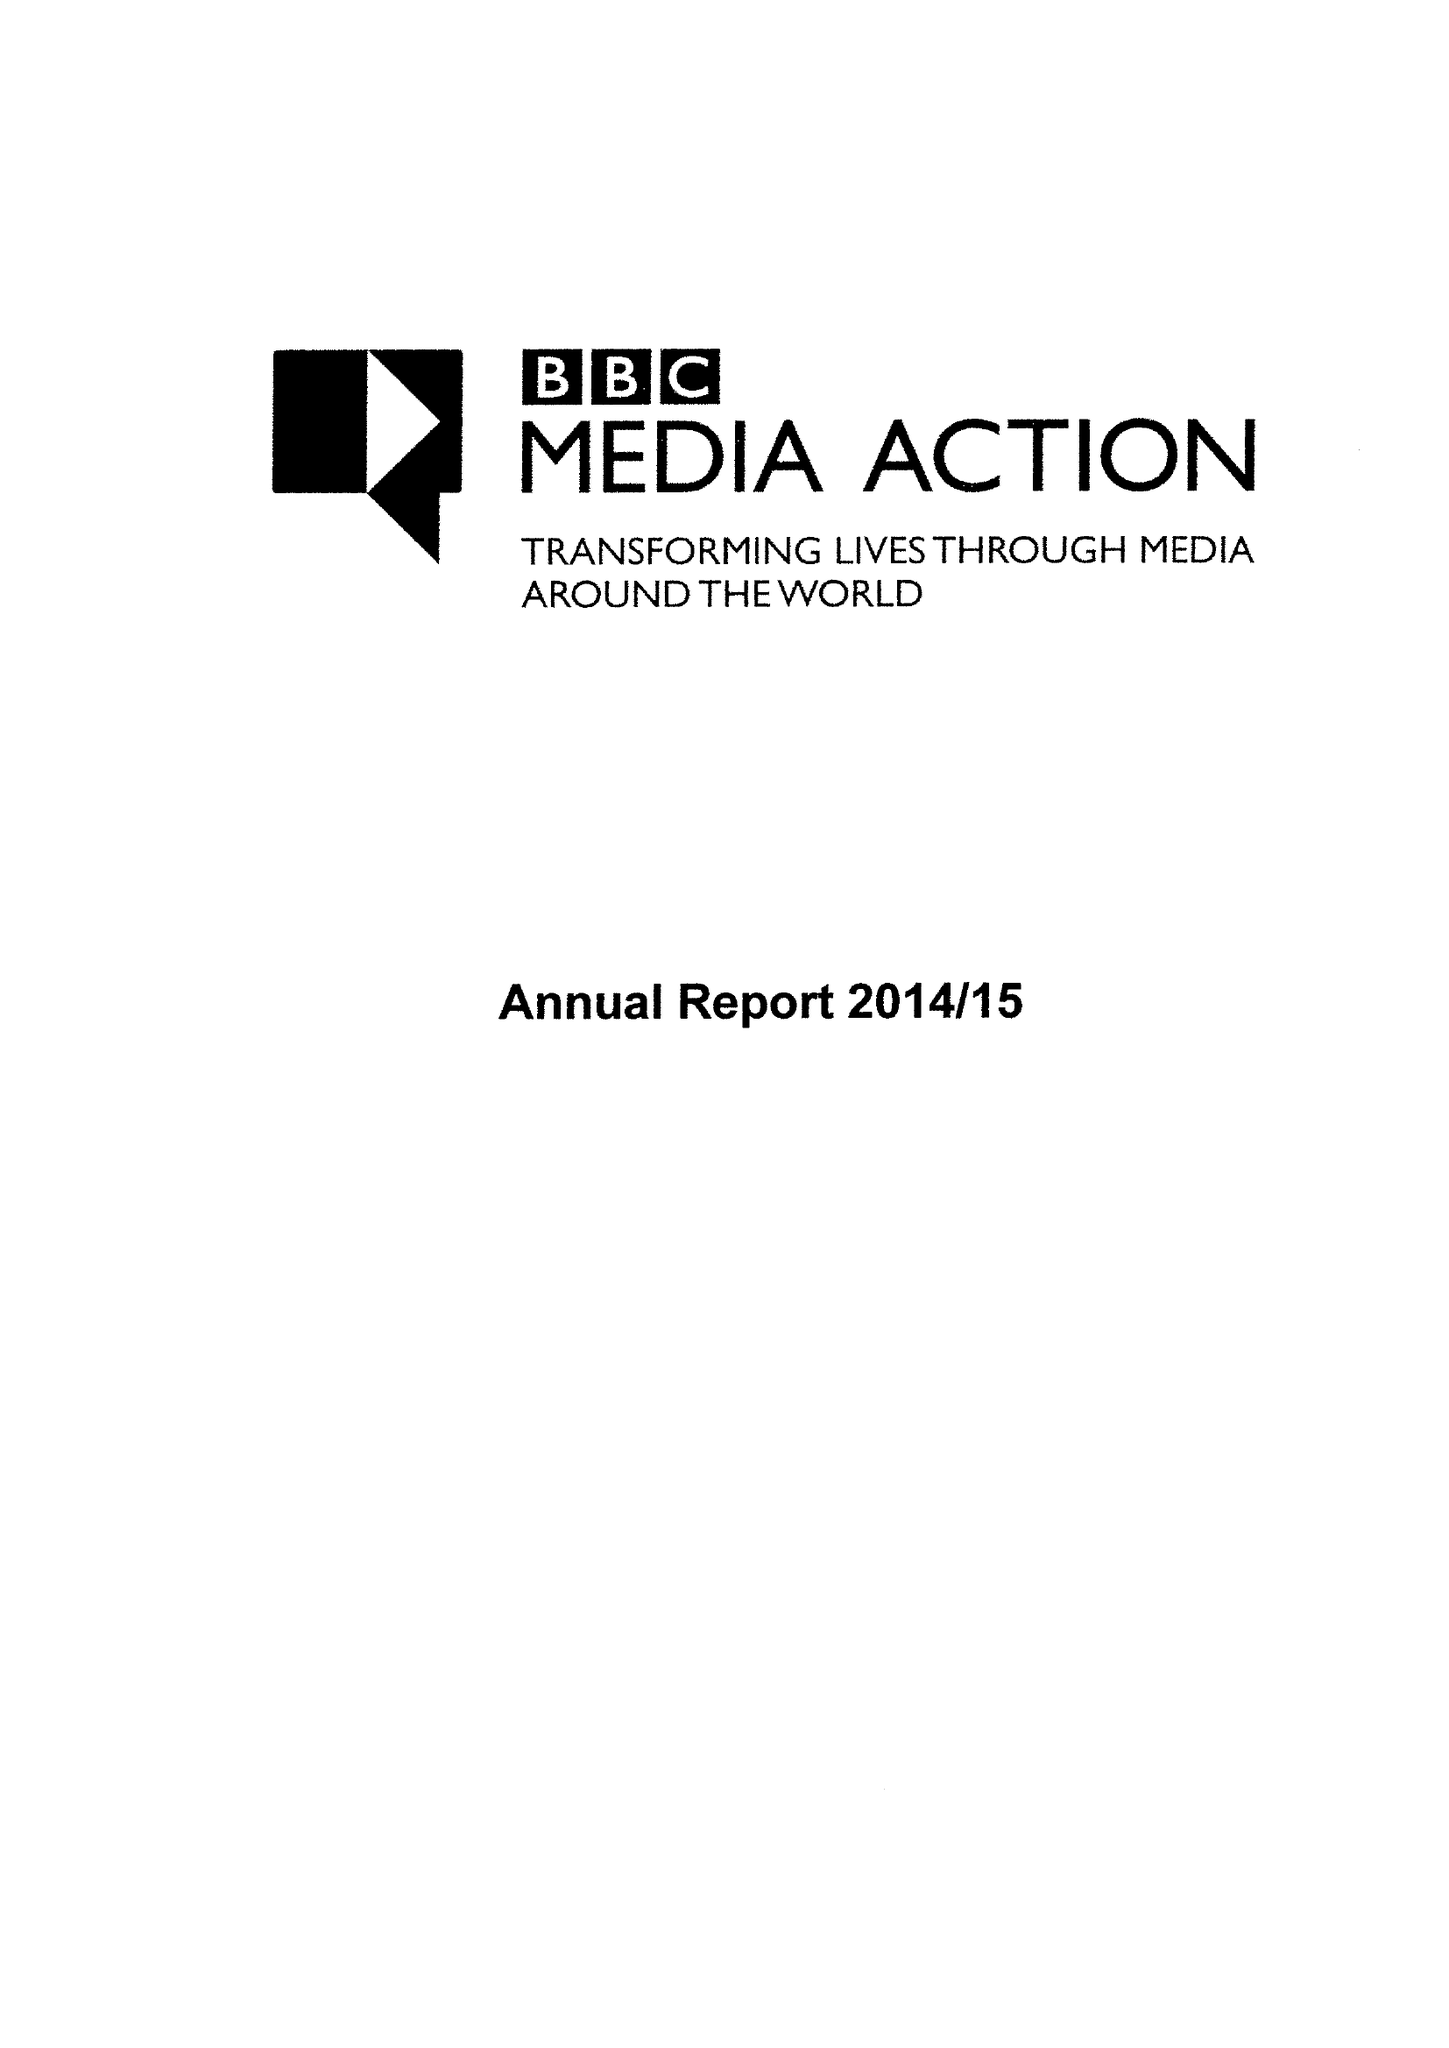What is the value for the report_date?
Answer the question using a single word or phrase. 2015-03-31 